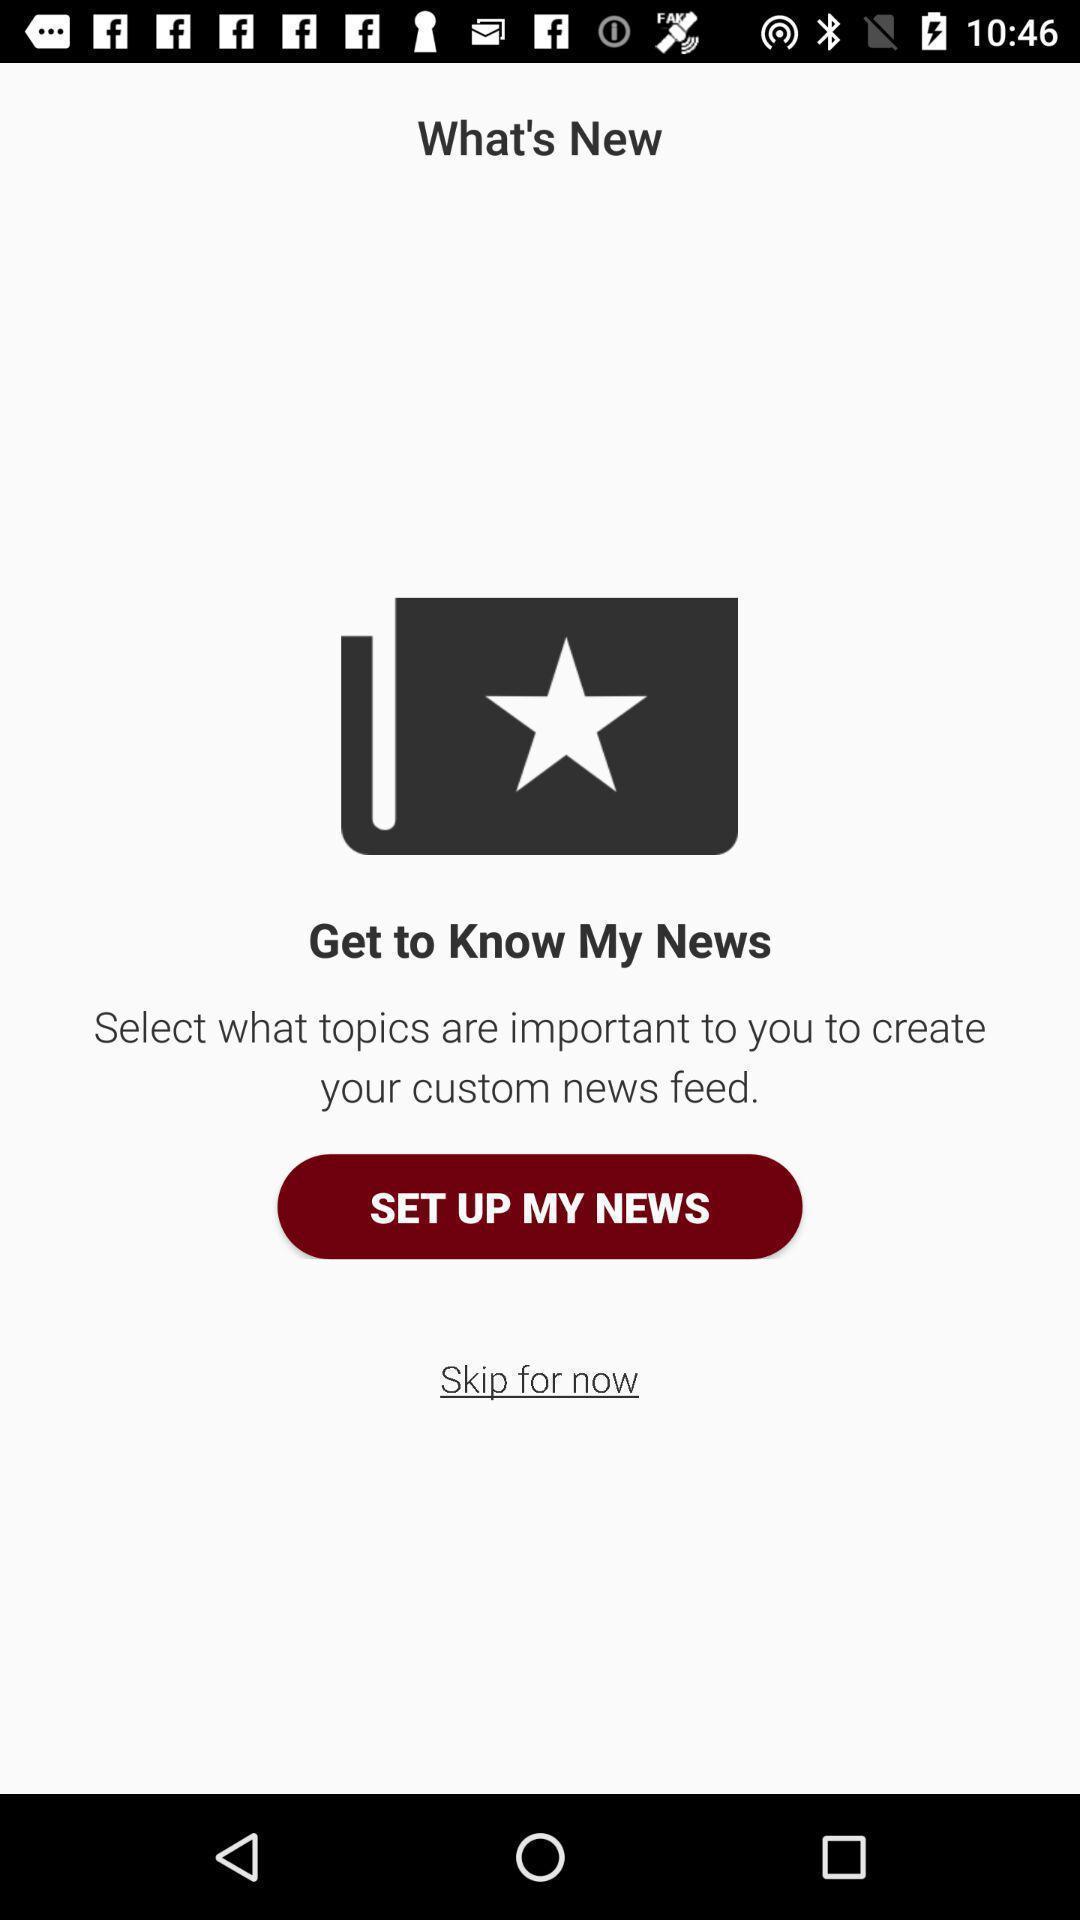What is the overall content of this screenshot? Screen displaying the page to setup. 